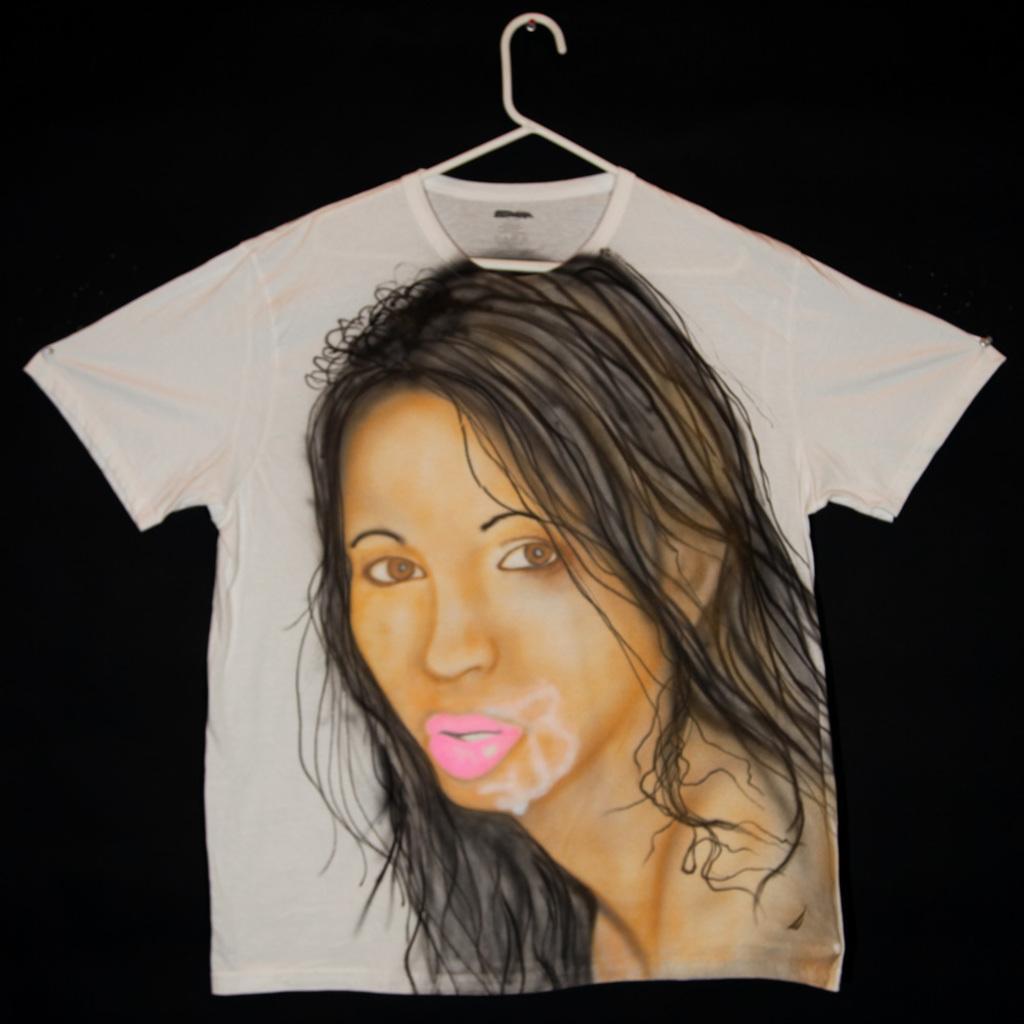Could you give a brief overview of what you see in this image? In this image we can see a T-shirt with an image of a lady on it. The background of the image is black in color. 